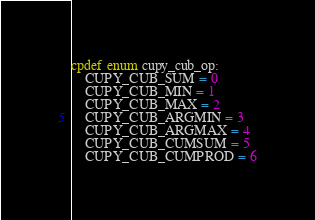<code> <loc_0><loc_0><loc_500><loc_500><_Cython_>cpdef enum cupy_cub_op:
    CUPY_CUB_SUM = 0
    CUPY_CUB_MIN = 1
    CUPY_CUB_MAX = 2
    CUPY_CUB_ARGMIN = 3
    CUPY_CUB_ARGMAX = 4
    CUPY_CUB_CUMSUM = 5
    CUPY_CUB_CUMPROD = 6
</code> 